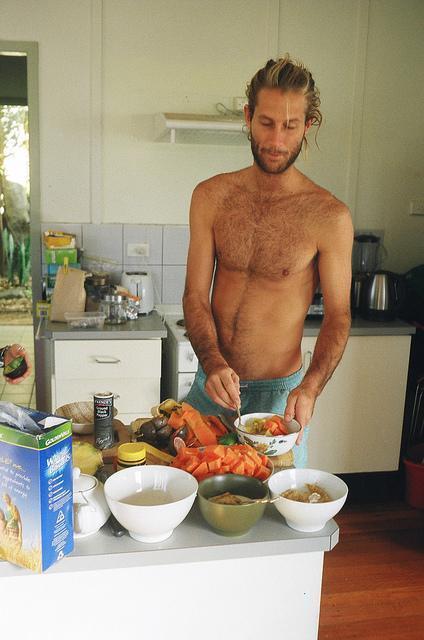How many bowls are there?
Give a very brief answer. 4. 